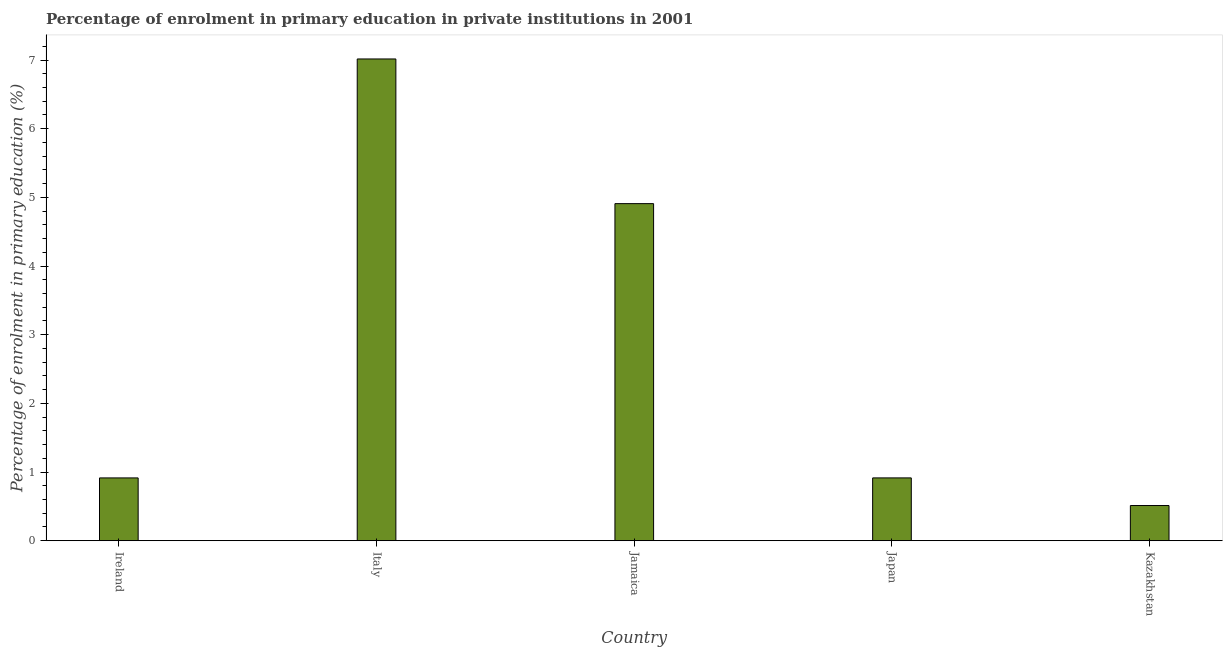Does the graph contain any zero values?
Ensure brevity in your answer.  No. What is the title of the graph?
Make the answer very short. Percentage of enrolment in primary education in private institutions in 2001. What is the label or title of the X-axis?
Offer a terse response. Country. What is the label or title of the Y-axis?
Offer a very short reply. Percentage of enrolment in primary education (%). What is the enrolment percentage in primary education in Japan?
Offer a terse response. 0.91. Across all countries, what is the maximum enrolment percentage in primary education?
Offer a very short reply. 7.02. Across all countries, what is the minimum enrolment percentage in primary education?
Provide a succinct answer. 0.51. In which country was the enrolment percentage in primary education maximum?
Keep it short and to the point. Italy. In which country was the enrolment percentage in primary education minimum?
Make the answer very short. Kazakhstan. What is the sum of the enrolment percentage in primary education?
Make the answer very short. 14.27. What is the difference between the enrolment percentage in primary education in Ireland and Kazakhstan?
Keep it short and to the point. 0.4. What is the average enrolment percentage in primary education per country?
Offer a terse response. 2.85. What is the median enrolment percentage in primary education?
Provide a short and direct response. 0.91. In how many countries, is the enrolment percentage in primary education greater than 4.2 %?
Offer a terse response. 2. What is the ratio of the enrolment percentage in primary education in Italy to that in Jamaica?
Provide a succinct answer. 1.43. Is the difference between the enrolment percentage in primary education in Ireland and Japan greater than the difference between any two countries?
Your answer should be very brief. No. What is the difference between the highest and the second highest enrolment percentage in primary education?
Give a very brief answer. 2.11. Is the sum of the enrolment percentage in primary education in Italy and Japan greater than the maximum enrolment percentage in primary education across all countries?
Offer a very short reply. Yes. In how many countries, is the enrolment percentage in primary education greater than the average enrolment percentage in primary education taken over all countries?
Offer a very short reply. 2. How many countries are there in the graph?
Provide a short and direct response. 5. What is the difference between two consecutive major ticks on the Y-axis?
Keep it short and to the point. 1. Are the values on the major ticks of Y-axis written in scientific E-notation?
Offer a very short reply. No. What is the Percentage of enrolment in primary education (%) of Ireland?
Keep it short and to the point. 0.91. What is the Percentage of enrolment in primary education (%) of Italy?
Make the answer very short. 7.02. What is the Percentage of enrolment in primary education (%) in Jamaica?
Your answer should be very brief. 4.91. What is the Percentage of enrolment in primary education (%) of Japan?
Your answer should be very brief. 0.91. What is the Percentage of enrolment in primary education (%) in Kazakhstan?
Your answer should be very brief. 0.51. What is the difference between the Percentage of enrolment in primary education (%) in Ireland and Italy?
Your answer should be compact. -6.1. What is the difference between the Percentage of enrolment in primary education (%) in Ireland and Jamaica?
Offer a terse response. -3.99. What is the difference between the Percentage of enrolment in primary education (%) in Ireland and Japan?
Your response must be concise. -0. What is the difference between the Percentage of enrolment in primary education (%) in Ireland and Kazakhstan?
Your answer should be very brief. 0.4. What is the difference between the Percentage of enrolment in primary education (%) in Italy and Jamaica?
Provide a succinct answer. 2.11. What is the difference between the Percentage of enrolment in primary education (%) in Italy and Japan?
Ensure brevity in your answer.  6.1. What is the difference between the Percentage of enrolment in primary education (%) in Italy and Kazakhstan?
Your answer should be compact. 6.5. What is the difference between the Percentage of enrolment in primary education (%) in Jamaica and Japan?
Offer a terse response. 3.99. What is the difference between the Percentage of enrolment in primary education (%) in Jamaica and Kazakhstan?
Give a very brief answer. 4.4. What is the difference between the Percentage of enrolment in primary education (%) in Japan and Kazakhstan?
Ensure brevity in your answer.  0.4. What is the ratio of the Percentage of enrolment in primary education (%) in Ireland to that in Italy?
Keep it short and to the point. 0.13. What is the ratio of the Percentage of enrolment in primary education (%) in Ireland to that in Jamaica?
Your response must be concise. 0.19. What is the ratio of the Percentage of enrolment in primary education (%) in Ireland to that in Kazakhstan?
Your answer should be very brief. 1.78. What is the ratio of the Percentage of enrolment in primary education (%) in Italy to that in Jamaica?
Your response must be concise. 1.43. What is the ratio of the Percentage of enrolment in primary education (%) in Italy to that in Japan?
Keep it short and to the point. 7.67. What is the ratio of the Percentage of enrolment in primary education (%) in Italy to that in Kazakhstan?
Provide a succinct answer. 13.69. What is the ratio of the Percentage of enrolment in primary education (%) in Jamaica to that in Japan?
Provide a succinct answer. 5.37. What is the ratio of the Percentage of enrolment in primary education (%) in Jamaica to that in Kazakhstan?
Provide a succinct answer. 9.58. What is the ratio of the Percentage of enrolment in primary education (%) in Japan to that in Kazakhstan?
Your answer should be compact. 1.78. 